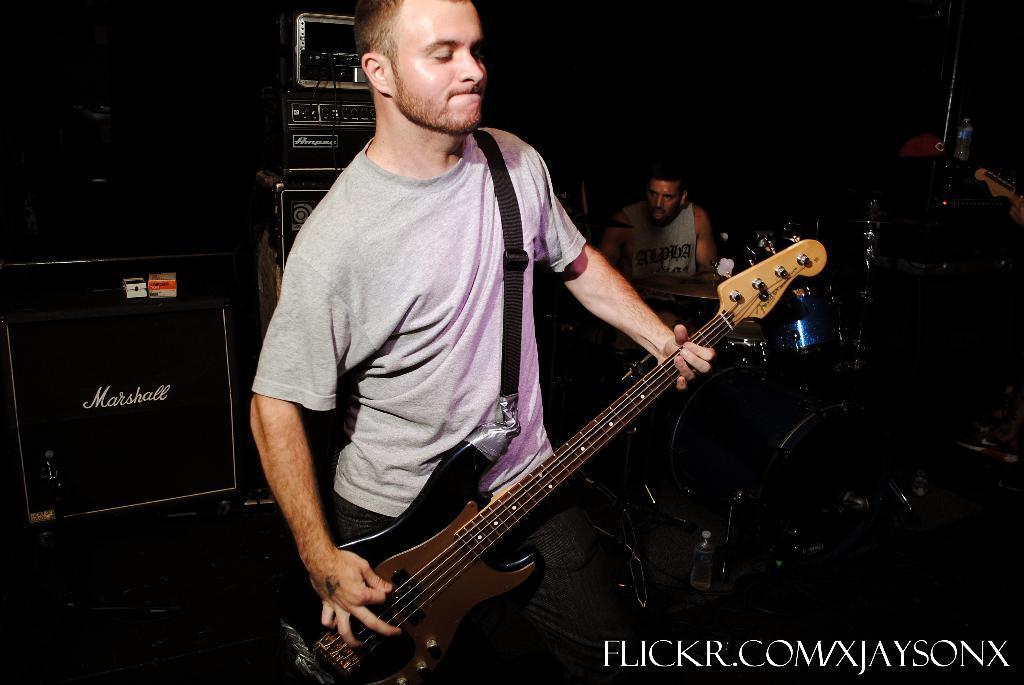Could you give a brief overview of what you see in this image? In this image these are playing a musical instruments. 